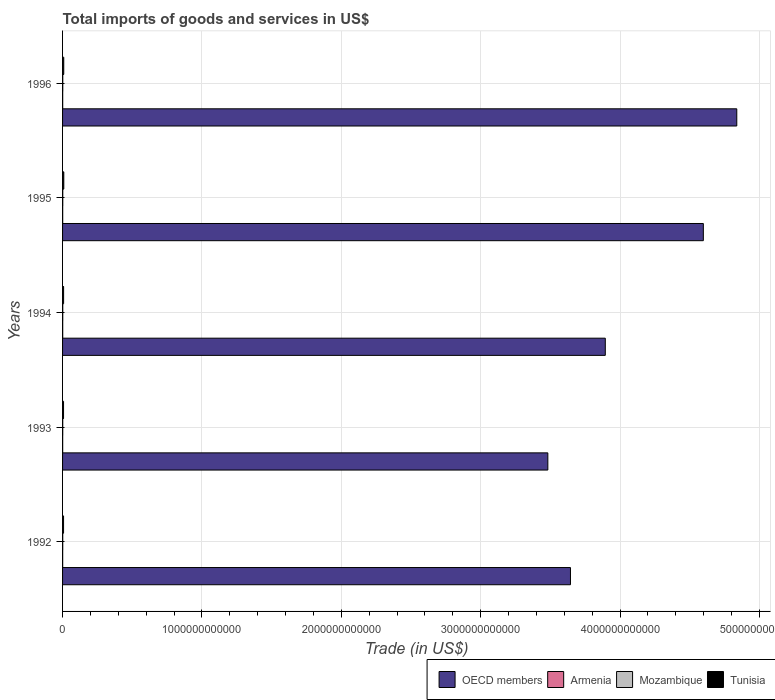How many different coloured bars are there?
Offer a terse response. 4. Are the number of bars per tick equal to the number of legend labels?
Provide a succinct answer. Yes. What is the total imports of goods and services in Mozambique in 1994?
Ensure brevity in your answer.  1.27e+09. Across all years, what is the maximum total imports of goods and services in OECD members?
Make the answer very short. 4.84e+12. Across all years, what is the minimum total imports of goods and services in Tunisia?
Your response must be concise. 7.01e+09. In which year was the total imports of goods and services in Mozambique maximum?
Offer a very short reply. 1995. In which year was the total imports of goods and services in Mozambique minimum?
Offer a terse response. 1993. What is the total total imports of goods and services in Mozambique in the graph?
Your response must be concise. 6.58e+09. What is the difference between the total imports of goods and services in Mozambique in 1993 and that in 1995?
Your answer should be very brief. -2.32e+08. What is the difference between the total imports of goods and services in OECD members in 1994 and the total imports of goods and services in Tunisia in 1995?
Provide a succinct answer. 3.89e+12. What is the average total imports of goods and services in Mozambique per year?
Your answer should be very brief. 1.32e+09. In the year 1992, what is the difference between the total imports of goods and services in OECD members and total imports of goods and services in Mozambique?
Provide a succinct answer. 3.64e+12. In how many years, is the total imports of goods and services in Tunisia greater than 4800000000000 US$?
Your answer should be very brief. 0. What is the ratio of the total imports of goods and services in Armenia in 1993 to that in 1995?
Make the answer very short. 0.8. Is the total imports of goods and services in Armenia in 1992 less than that in 1993?
Your answer should be very brief. No. What is the difference between the highest and the second highest total imports of goods and services in Mozambique?
Your answer should be very brief. 6.62e+06. What is the difference between the highest and the lowest total imports of goods and services in Armenia?
Keep it short and to the point. 2.32e+08. In how many years, is the total imports of goods and services in Mozambique greater than the average total imports of goods and services in Mozambique taken over all years?
Keep it short and to the point. 2. Is it the case that in every year, the sum of the total imports of goods and services in Mozambique and total imports of goods and services in OECD members is greater than the sum of total imports of goods and services in Tunisia and total imports of goods and services in Armenia?
Your answer should be very brief. Yes. What does the 1st bar from the top in 1994 represents?
Your answer should be compact. Tunisia. What does the 1st bar from the bottom in 1996 represents?
Provide a succinct answer. OECD members. Are all the bars in the graph horizontal?
Your answer should be compact. Yes. How many years are there in the graph?
Provide a succinct answer. 5. What is the difference between two consecutive major ticks on the X-axis?
Keep it short and to the point. 1.00e+12. Does the graph contain any zero values?
Provide a succinct answer. No. Where does the legend appear in the graph?
Make the answer very short. Bottom right. How many legend labels are there?
Your response must be concise. 4. How are the legend labels stacked?
Give a very brief answer. Horizontal. What is the title of the graph?
Ensure brevity in your answer.  Total imports of goods and services in US$. What is the label or title of the X-axis?
Give a very brief answer. Trade (in US$). What is the Trade (in US$) in OECD members in 1992?
Your answer should be compact. 3.64e+12. What is the Trade (in US$) in Armenia in 1992?
Your answer should be very brief. 7.80e+08. What is the Trade (in US$) in Mozambique in 1992?
Give a very brief answer. 1.24e+09. What is the Trade (in US$) of Tunisia in 1992?
Provide a short and direct response. 7.20e+09. What is the Trade (in US$) of OECD members in 1993?
Make the answer very short. 3.48e+12. What is the Trade (in US$) in Armenia in 1993?
Provide a short and direct response. 7.30e+08. What is the Trade (in US$) of Mozambique in 1993?
Give a very brief answer. 1.20e+09. What is the Trade (in US$) of Tunisia in 1993?
Ensure brevity in your answer.  7.01e+09. What is the Trade (in US$) of OECD members in 1994?
Provide a succinct answer. 3.89e+12. What is the Trade (in US$) of Armenia in 1994?
Your response must be concise. 9.61e+08. What is the Trade (in US$) of Mozambique in 1994?
Make the answer very short. 1.27e+09. What is the Trade (in US$) of Tunisia in 1994?
Offer a very short reply. 7.48e+09. What is the Trade (in US$) in OECD members in 1995?
Your answer should be very brief. 4.60e+12. What is the Trade (in US$) of Armenia in 1995?
Your answer should be compact. 9.13e+08. What is the Trade (in US$) of Mozambique in 1995?
Your response must be concise. 1.44e+09. What is the Trade (in US$) in Tunisia in 1995?
Your answer should be very brief. 8.80e+09. What is the Trade (in US$) in OECD members in 1996?
Make the answer very short. 4.84e+12. What is the Trade (in US$) in Armenia in 1996?
Your response must be concise. 8.94e+08. What is the Trade (in US$) in Mozambique in 1996?
Provide a succinct answer. 1.43e+09. What is the Trade (in US$) of Tunisia in 1996?
Provide a short and direct response. 8.54e+09. Across all years, what is the maximum Trade (in US$) of OECD members?
Ensure brevity in your answer.  4.84e+12. Across all years, what is the maximum Trade (in US$) of Armenia?
Keep it short and to the point. 9.61e+08. Across all years, what is the maximum Trade (in US$) in Mozambique?
Give a very brief answer. 1.44e+09. Across all years, what is the maximum Trade (in US$) in Tunisia?
Offer a terse response. 8.80e+09. Across all years, what is the minimum Trade (in US$) of OECD members?
Offer a terse response. 3.48e+12. Across all years, what is the minimum Trade (in US$) of Armenia?
Provide a short and direct response. 7.30e+08. Across all years, what is the minimum Trade (in US$) in Mozambique?
Your answer should be very brief. 1.20e+09. Across all years, what is the minimum Trade (in US$) in Tunisia?
Your response must be concise. 7.01e+09. What is the total Trade (in US$) of OECD members in the graph?
Ensure brevity in your answer.  2.05e+13. What is the total Trade (in US$) in Armenia in the graph?
Your response must be concise. 4.28e+09. What is the total Trade (in US$) in Mozambique in the graph?
Your answer should be compact. 6.58e+09. What is the total Trade (in US$) in Tunisia in the graph?
Give a very brief answer. 3.90e+1. What is the difference between the Trade (in US$) of OECD members in 1992 and that in 1993?
Provide a succinct answer. 1.62e+11. What is the difference between the Trade (in US$) of Armenia in 1992 and that in 1993?
Give a very brief answer. 4.97e+07. What is the difference between the Trade (in US$) in Mozambique in 1992 and that in 1993?
Make the answer very short. 3.84e+07. What is the difference between the Trade (in US$) of Tunisia in 1992 and that in 1993?
Offer a very short reply. 1.94e+08. What is the difference between the Trade (in US$) of OECD members in 1992 and that in 1994?
Ensure brevity in your answer.  -2.50e+11. What is the difference between the Trade (in US$) in Armenia in 1992 and that in 1994?
Keep it short and to the point. -1.82e+08. What is the difference between the Trade (in US$) of Mozambique in 1992 and that in 1994?
Your answer should be compact. -3.20e+07. What is the difference between the Trade (in US$) in Tunisia in 1992 and that in 1994?
Your answer should be very brief. -2.83e+08. What is the difference between the Trade (in US$) in OECD members in 1992 and that in 1995?
Give a very brief answer. -9.53e+11. What is the difference between the Trade (in US$) in Armenia in 1992 and that in 1995?
Make the answer very short. -1.34e+08. What is the difference between the Trade (in US$) in Mozambique in 1992 and that in 1995?
Offer a terse response. -1.94e+08. What is the difference between the Trade (in US$) in Tunisia in 1992 and that in 1995?
Provide a succinct answer. -1.60e+09. What is the difference between the Trade (in US$) in OECD members in 1992 and that in 1996?
Your answer should be very brief. -1.19e+12. What is the difference between the Trade (in US$) in Armenia in 1992 and that in 1996?
Your response must be concise. -1.15e+08. What is the difference between the Trade (in US$) in Mozambique in 1992 and that in 1996?
Provide a short and direct response. -1.87e+08. What is the difference between the Trade (in US$) in Tunisia in 1992 and that in 1996?
Offer a very short reply. -1.34e+09. What is the difference between the Trade (in US$) of OECD members in 1993 and that in 1994?
Your answer should be compact. -4.12e+11. What is the difference between the Trade (in US$) of Armenia in 1993 and that in 1994?
Your answer should be compact. -2.32e+08. What is the difference between the Trade (in US$) of Mozambique in 1993 and that in 1994?
Offer a terse response. -7.05e+07. What is the difference between the Trade (in US$) in Tunisia in 1993 and that in 1994?
Your answer should be very brief. -4.76e+08. What is the difference between the Trade (in US$) of OECD members in 1993 and that in 1995?
Your answer should be very brief. -1.12e+12. What is the difference between the Trade (in US$) of Armenia in 1993 and that in 1995?
Your answer should be very brief. -1.83e+08. What is the difference between the Trade (in US$) of Mozambique in 1993 and that in 1995?
Offer a terse response. -2.32e+08. What is the difference between the Trade (in US$) of Tunisia in 1993 and that in 1995?
Provide a short and direct response. -1.79e+09. What is the difference between the Trade (in US$) in OECD members in 1993 and that in 1996?
Your response must be concise. -1.36e+12. What is the difference between the Trade (in US$) of Armenia in 1993 and that in 1996?
Your answer should be very brief. -1.64e+08. What is the difference between the Trade (in US$) of Mozambique in 1993 and that in 1996?
Keep it short and to the point. -2.26e+08. What is the difference between the Trade (in US$) in Tunisia in 1993 and that in 1996?
Your response must be concise. -1.53e+09. What is the difference between the Trade (in US$) in OECD members in 1994 and that in 1995?
Make the answer very short. -7.04e+11. What is the difference between the Trade (in US$) in Armenia in 1994 and that in 1995?
Make the answer very short. 4.83e+07. What is the difference between the Trade (in US$) in Mozambique in 1994 and that in 1995?
Your answer should be very brief. -1.62e+08. What is the difference between the Trade (in US$) in Tunisia in 1994 and that in 1995?
Provide a short and direct response. -1.32e+09. What is the difference between the Trade (in US$) in OECD members in 1994 and that in 1996?
Your answer should be very brief. -9.43e+11. What is the difference between the Trade (in US$) in Armenia in 1994 and that in 1996?
Provide a short and direct response. 6.73e+07. What is the difference between the Trade (in US$) of Mozambique in 1994 and that in 1996?
Offer a terse response. -1.55e+08. What is the difference between the Trade (in US$) in Tunisia in 1994 and that in 1996?
Provide a succinct answer. -1.06e+09. What is the difference between the Trade (in US$) of OECD members in 1995 and that in 1996?
Offer a terse response. -2.40e+11. What is the difference between the Trade (in US$) in Armenia in 1995 and that in 1996?
Make the answer very short. 1.90e+07. What is the difference between the Trade (in US$) in Mozambique in 1995 and that in 1996?
Ensure brevity in your answer.  6.62e+06. What is the difference between the Trade (in US$) of Tunisia in 1995 and that in 1996?
Ensure brevity in your answer.  2.59e+08. What is the difference between the Trade (in US$) in OECD members in 1992 and the Trade (in US$) in Armenia in 1993?
Make the answer very short. 3.64e+12. What is the difference between the Trade (in US$) of OECD members in 1992 and the Trade (in US$) of Mozambique in 1993?
Provide a succinct answer. 3.64e+12. What is the difference between the Trade (in US$) in OECD members in 1992 and the Trade (in US$) in Tunisia in 1993?
Offer a terse response. 3.64e+12. What is the difference between the Trade (in US$) in Armenia in 1992 and the Trade (in US$) in Mozambique in 1993?
Make the answer very short. -4.24e+08. What is the difference between the Trade (in US$) in Armenia in 1992 and the Trade (in US$) in Tunisia in 1993?
Provide a short and direct response. -6.23e+09. What is the difference between the Trade (in US$) of Mozambique in 1992 and the Trade (in US$) of Tunisia in 1993?
Give a very brief answer. -5.77e+09. What is the difference between the Trade (in US$) in OECD members in 1992 and the Trade (in US$) in Armenia in 1994?
Provide a short and direct response. 3.64e+12. What is the difference between the Trade (in US$) in OECD members in 1992 and the Trade (in US$) in Mozambique in 1994?
Your response must be concise. 3.64e+12. What is the difference between the Trade (in US$) in OECD members in 1992 and the Trade (in US$) in Tunisia in 1994?
Give a very brief answer. 3.64e+12. What is the difference between the Trade (in US$) of Armenia in 1992 and the Trade (in US$) of Mozambique in 1994?
Your answer should be compact. -4.94e+08. What is the difference between the Trade (in US$) in Armenia in 1992 and the Trade (in US$) in Tunisia in 1994?
Give a very brief answer. -6.70e+09. What is the difference between the Trade (in US$) of Mozambique in 1992 and the Trade (in US$) of Tunisia in 1994?
Your response must be concise. -6.24e+09. What is the difference between the Trade (in US$) of OECD members in 1992 and the Trade (in US$) of Armenia in 1995?
Make the answer very short. 3.64e+12. What is the difference between the Trade (in US$) of OECD members in 1992 and the Trade (in US$) of Mozambique in 1995?
Give a very brief answer. 3.64e+12. What is the difference between the Trade (in US$) of OECD members in 1992 and the Trade (in US$) of Tunisia in 1995?
Your answer should be very brief. 3.64e+12. What is the difference between the Trade (in US$) in Armenia in 1992 and the Trade (in US$) in Mozambique in 1995?
Your answer should be very brief. -6.56e+08. What is the difference between the Trade (in US$) in Armenia in 1992 and the Trade (in US$) in Tunisia in 1995?
Ensure brevity in your answer.  -8.02e+09. What is the difference between the Trade (in US$) of Mozambique in 1992 and the Trade (in US$) of Tunisia in 1995?
Offer a very short reply. -7.56e+09. What is the difference between the Trade (in US$) in OECD members in 1992 and the Trade (in US$) in Armenia in 1996?
Provide a short and direct response. 3.64e+12. What is the difference between the Trade (in US$) in OECD members in 1992 and the Trade (in US$) in Mozambique in 1996?
Offer a terse response. 3.64e+12. What is the difference between the Trade (in US$) of OECD members in 1992 and the Trade (in US$) of Tunisia in 1996?
Provide a short and direct response. 3.64e+12. What is the difference between the Trade (in US$) of Armenia in 1992 and the Trade (in US$) of Mozambique in 1996?
Give a very brief answer. -6.49e+08. What is the difference between the Trade (in US$) of Armenia in 1992 and the Trade (in US$) of Tunisia in 1996?
Offer a terse response. -7.76e+09. What is the difference between the Trade (in US$) of Mozambique in 1992 and the Trade (in US$) of Tunisia in 1996?
Provide a short and direct response. -7.30e+09. What is the difference between the Trade (in US$) of OECD members in 1993 and the Trade (in US$) of Armenia in 1994?
Provide a short and direct response. 3.48e+12. What is the difference between the Trade (in US$) in OECD members in 1993 and the Trade (in US$) in Mozambique in 1994?
Offer a terse response. 3.48e+12. What is the difference between the Trade (in US$) in OECD members in 1993 and the Trade (in US$) in Tunisia in 1994?
Provide a short and direct response. 3.47e+12. What is the difference between the Trade (in US$) of Armenia in 1993 and the Trade (in US$) of Mozambique in 1994?
Your answer should be compact. -5.44e+08. What is the difference between the Trade (in US$) of Armenia in 1993 and the Trade (in US$) of Tunisia in 1994?
Your answer should be very brief. -6.75e+09. What is the difference between the Trade (in US$) in Mozambique in 1993 and the Trade (in US$) in Tunisia in 1994?
Your answer should be compact. -6.28e+09. What is the difference between the Trade (in US$) in OECD members in 1993 and the Trade (in US$) in Armenia in 1995?
Your answer should be compact. 3.48e+12. What is the difference between the Trade (in US$) of OECD members in 1993 and the Trade (in US$) of Mozambique in 1995?
Provide a short and direct response. 3.48e+12. What is the difference between the Trade (in US$) of OECD members in 1993 and the Trade (in US$) of Tunisia in 1995?
Offer a very short reply. 3.47e+12. What is the difference between the Trade (in US$) in Armenia in 1993 and the Trade (in US$) in Mozambique in 1995?
Provide a succinct answer. -7.06e+08. What is the difference between the Trade (in US$) in Armenia in 1993 and the Trade (in US$) in Tunisia in 1995?
Offer a terse response. -8.07e+09. What is the difference between the Trade (in US$) of Mozambique in 1993 and the Trade (in US$) of Tunisia in 1995?
Provide a short and direct response. -7.60e+09. What is the difference between the Trade (in US$) in OECD members in 1993 and the Trade (in US$) in Armenia in 1996?
Provide a short and direct response. 3.48e+12. What is the difference between the Trade (in US$) in OECD members in 1993 and the Trade (in US$) in Mozambique in 1996?
Provide a short and direct response. 3.48e+12. What is the difference between the Trade (in US$) of OECD members in 1993 and the Trade (in US$) of Tunisia in 1996?
Ensure brevity in your answer.  3.47e+12. What is the difference between the Trade (in US$) in Armenia in 1993 and the Trade (in US$) in Mozambique in 1996?
Provide a short and direct response. -6.99e+08. What is the difference between the Trade (in US$) of Armenia in 1993 and the Trade (in US$) of Tunisia in 1996?
Give a very brief answer. -7.81e+09. What is the difference between the Trade (in US$) in Mozambique in 1993 and the Trade (in US$) in Tunisia in 1996?
Offer a terse response. -7.34e+09. What is the difference between the Trade (in US$) in OECD members in 1994 and the Trade (in US$) in Armenia in 1995?
Offer a very short reply. 3.89e+12. What is the difference between the Trade (in US$) of OECD members in 1994 and the Trade (in US$) of Mozambique in 1995?
Provide a succinct answer. 3.89e+12. What is the difference between the Trade (in US$) in OECD members in 1994 and the Trade (in US$) in Tunisia in 1995?
Give a very brief answer. 3.89e+12. What is the difference between the Trade (in US$) of Armenia in 1994 and the Trade (in US$) of Mozambique in 1995?
Your answer should be compact. -4.74e+08. What is the difference between the Trade (in US$) in Armenia in 1994 and the Trade (in US$) in Tunisia in 1995?
Provide a succinct answer. -7.84e+09. What is the difference between the Trade (in US$) of Mozambique in 1994 and the Trade (in US$) of Tunisia in 1995?
Give a very brief answer. -7.53e+09. What is the difference between the Trade (in US$) in OECD members in 1994 and the Trade (in US$) in Armenia in 1996?
Provide a succinct answer. 3.89e+12. What is the difference between the Trade (in US$) in OECD members in 1994 and the Trade (in US$) in Mozambique in 1996?
Provide a short and direct response. 3.89e+12. What is the difference between the Trade (in US$) in OECD members in 1994 and the Trade (in US$) in Tunisia in 1996?
Provide a succinct answer. 3.89e+12. What is the difference between the Trade (in US$) in Armenia in 1994 and the Trade (in US$) in Mozambique in 1996?
Offer a terse response. -4.67e+08. What is the difference between the Trade (in US$) in Armenia in 1994 and the Trade (in US$) in Tunisia in 1996?
Give a very brief answer. -7.58e+09. What is the difference between the Trade (in US$) in Mozambique in 1994 and the Trade (in US$) in Tunisia in 1996?
Provide a short and direct response. -7.27e+09. What is the difference between the Trade (in US$) in OECD members in 1995 and the Trade (in US$) in Armenia in 1996?
Provide a succinct answer. 4.60e+12. What is the difference between the Trade (in US$) of OECD members in 1995 and the Trade (in US$) of Mozambique in 1996?
Provide a succinct answer. 4.60e+12. What is the difference between the Trade (in US$) of OECD members in 1995 and the Trade (in US$) of Tunisia in 1996?
Give a very brief answer. 4.59e+12. What is the difference between the Trade (in US$) of Armenia in 1995 and the Trade (in US$) of Mozambique in 1996?
Ensure brevity in your answer.  -5.16e+08. What is the difference between the Trade (in US$) of Armenia in 1995 and the Trade (in US$) of Tunisia in 1996?
Offer a very short reply. -7.63e+09. What is the difference between the Trade (in US$) in Mozambique in 1995 and the Trade (in US$) in Tunisia in 1996?
Offer a terse response. -7.11e+09. What is the average Trade (in US$) of OECD members per year?
Provide a succinct answer. 4.09e+12. What is the average Trade (in US$) in Armenia per year?
Offer a very short reply. 8.56e+08. What is the average Trade (in US$) in Mozambique per year?
Your response must be concise. 1.32e+09. What is the average Trade (in US$) in Tunisia per year?
Ensure brevity in your answer.  7.81e+09. In the year 1992, what is the difference between the Trade (in US$) of OECD members and Trade (in US$) of Armenia?
Ensure brevity in your answer.  3.64e+12. In the year 1992, what is the difference between the Trade (in US$) of OECD members and Trade (in US$) of Mozambique?
Give a very brief answer. 3.64e+12. In the year 1992, what is the difference between the Trade (in US$) in OECD members and Trade (in US$) in Tunisia?
Give a very brief answer. 3.64e+12. In the year 1992, what is the difference between the Trade (in US$) of Armenia and Trade (in US$) of Mozambique?
Keep it short and to the point. -4.62e+08. In the year 1992, what is the difference between the Trade (in US$) of Armenia and Trade (in US$) of Tunisia?
Offer a terse response. -6.42e+09. In the year 1992, what is the difference between the Trade (in US$) of Mozambique and Trade (in US$) of Tunisia?
Keep it short and to the point. -5.96e+09. In the year 1993, what is the difference between the Trade (in US$) of OECD members and Trade (in US$) of Armenia?
Provide a succinct answer. 3.48e+12. In the year 1993, what is the difference between the Trade (in US$) of OECD members and Trade (in US$) of Mozambique?
Give a very brief answer. 3.48e+12. In the year 1993, what is the difference between the Trade (in US$) in OECD members and Trade (in US$) in Tunisia?
Keep it short and to the point. 3.48e+12. In the year 1993, what is the difference between the Trade (in US$) in Armenia and Trade (in US$) in Mozambique?
Give a very brief answer. -4.73e+08. In the year 1993, what is the difference between the Trade (in US$) of Armenia and Trade (in US$) of Tunisia?
Provide a succinct answer. -6.28e+09. In the year 1993, what is the difference between the Trade (in US$) in Mozambique and Trade (in US$) in Tunisia?
Ensure brevity in your answer.  -5.80e+09. In the year 1994, what is the difference between the Trade (in US$) in OECD members and Trade (in US$) in Armenia?
Offer a very short reply. 3.89e+12. In the year 1994, what is the difference between the Trade (in US$) of OECD members and Trade (in US$) of Mozambique?
Your answer should be compact. 3.89e+12. In the year 1994, what is the difference between the Trade (in US$) in OECD members and Trade (in US$) in Tunisia?
Provide a succinct answer. 3.89e+12. In the year 1994, what is the difference between the Trade (in US$) in Armenia and Trade (in US$) in Mozambique?
Your answer should be compact. -3.12e+08. In the year 1994, what is the difference between the Trade (in US$) of Armenia and Trade (in US$) of Tunisia?
Provide a succinct answer. -6.52e+09. In the year 1994, what is the difference between the Trade (in US$) of Mozambique and Trade (in US$) of Tunisia?
Your answer should be very brief. -6.21e+09. In the year 1995, what is the difference between the Trade (in US$) in OECD members and Trade (in US$) in Armenia?
Offer a terse response. 4.60e+12. In the year 1995, what is the difference between the Trade (in US$) in OECD members and Trade (in US$) in Mozambique?
Your answer should be very brief. 4.60e+12. In the year 1995, what is the difference between the Trade (in US$) in OECD members and Trade (in US$) in Tunisia?
Provide a short and direct response. 4.59e+12. In the year 1995, what is the difference between the Trade (in US$) of Armenia and Trade (in US$) of Mozambique?
Your answer should be very brief. -5.22e+08. In the year 1995, what is the difference between the Trade (in US$) in Armenia and Trade (in US$) in Tunisia?
Offer a very short reply. -7.89e+09. In the year 1995, what is the difference between the Trade (in US$) in Mozambique and Trade (in US$) in Tunisia?
Your answer should be compact. -7.37e+09. In the year 1996, what is the difference between the Trade (in US$) of OECD members and Trade (in US$) of Armenia?
Provide a succinct answer. 4.84e+12. In the year 1996, what is the difference between the Trade (in US$) of OECD members and Trade (in US$) of Mozambique?
Provide a succinct answer. 4.84e+12. In the year 1996, what is the difference between the Trade (in US$) in OECD members and Trade (in US$) in Tunisia?
Make the answer very short. 4.83e+12. In the year 1996, what is the difference between the Trade (in US$) of Armenia and Trade (in US$) of Mozambique?
Your answer should be compact. -5.35e+08. In the year 1996, what is the difference between the Trade (in US$) in Armenia and Trade (in US$) in Tunisia?
Your answer should be very brief. -7.65e+09. In the year 1996, what is the difference between the Trade (in US$) of Mozambique and Trade (in US$) of Tunisia?
Your answer should be compact. -7.11e+09. What is the ratio of the Trade (in US$) of OECD members in 1992 to that in 1993?
Keep it short and to the point. 1.05. What is the ratio of the Trade (in US$) of Armenia in 1992 to that in 1993?
Your answer should be compact. 1.07. What is the ratio of the Trade (in US$) of Mozambique in 1992 to that in 1993?
Keep it short and to the point. 1.03. What is the ratio of the Trade (in US$) in Tunisia in 1992 to that in 1993?
Offer a terse response. 1.03. What is the ratio of the Trade (in US$) in OECD members in 1992 to that in 1994?
Your response must be concise. 0.94. What is the ratio of the Trade (in US$) of Armenia in 1992 to that in 1994?
Your response must be concise. 0.81. What is the ratio of the Trade (in US$) in Mozambique in 1992 to that in 1994?
Give a very brief answer. 0.97. What is the ratio of the Trade (in US$) of Tunisia in 1992 to that in 1994?
Your answer should be very brief. 0.96. What is the ratio of the Trade (in US$) of OECD members in 1992 to that in 1995?
Give a very brief answer. 0.79. What is the ratio of the Trade (in US$) in Armenia in 1992 to that in 1995?
Make the answer very short. 0.85. What is the ratio of the Trade (in US$) of Mozambique in 1992 to that in 1995?
Provide a short and direct response. 0.86. What is the ratio of the Trade (in US$) of Tunisia in 1992 to that in 1995?
Ensure brevity in your answer.  0.82. What is the ratio of the Trade (in US$) of OECD members in 1992 to that in 1996?
Your answer should be very brief. 0.75. What is the ratio of the Trade (in US$) in Armenia in 1992 to that in 1996?
Provide a succinct answer. 0.87. What is the ratio of the Trade (in US$) of Mozambique in 1992 to that in 1996?
Keep it short and to the point. 0.87. What is the ratio of the Trade (in US$) in Tunisia in 1992 to that in 1996?
Provide a succinct answer. 0.84. What is the ratio of the Trade (in US$) of OECD members in 1993 to that in 1994?
Keep it short and to the point. 0.89. What is the ratio of the Trade (in US$) in Armenia in 1993 to that in 1994?
Your response must be concise. 0.76. What is the ratio of the Trade (in US$) in Mozambique in 1993 to that in 1994?
Provide a succinct answer. 0.94. What is the ratio of the Trade (in US$) of Tunisia in 1993 to that in 1994?
Your response must be concise. 0.94. What is the ratio of the Trade (in US$) in OECD members in 1993 to that in 1995?
Ensure brevity in your answer.  0.76. What is the ratio of the Trade (in US$) of Armenia in 1993 to that in 1995?
Provide a succinct answer. 0.8. What is the ratio of the Trade (in US$) in Mozambique in 1993 to that in 1995?
Your answer should be compact. 0.84. What is the ratio of the Trade (in US$) in Tunisia in 1993 to that in 1995?
Your answer should be very brief. 0.8. What is the ratio of the Trade (in US$) of OECD members in 1993 to that in 1996?
Offer a terse response. 0.72. What is the ratio of the Trade (in US$) in Armenia in 1993 to that in 1996?
Give a very brief answer. 0.82. What is the ratio of the Trade (in US$) in Mozambique in 1993 to that in 1996?
Give a very brief answer. 0.84. What is the ratio of the Trade (in US$) of Tunisia in 1993 to that in 1996?
Your answer should be compact. 0.82. What is the ratio of the Trade (in US$) in OECD members in 1994 to that in 1995?
Your answer should be very brief. 0.85. What is the ratio of the Trade (in US$) of Armenia in 1994 to that in 1995?
Your answer should be very brief. 1.05. What is the ratio of the Trade (in US$) of Mozambique in 1994 to that in 1995?
Your answer should be very brief. 0.89. What is the ratio of the Trade (in US$) of Tunisia in 1994 to that in 1995?
Offer a very short reply. 0.85. What is the ratio of the Trade (in US$) of OECD members in 1994 to that in 1996?
Provide a short and direct response. 0.81. What is the ratio of the Trade (in US$) of Armenia in 1994 to that in 1996?
Your answer should be compact. 1.08. What is the ratio of the Trade (in US$) in Mozambique in 1994 to that in 1996?
Offer a terse response. 0.89. What is the ratio of the Trade (in US$) in Tunisia in 1994 to that in 1996?
Your answer should be compact. 0.88. What is the ratio of the Trade (in US$) in OECD members in 1995 to that in 1996?
Provide a short and direct response. 0.95. What is the ratio of the Trade (in US$) of Armenia in 1995 to that in 1996?
Your answer should be compact. 1.02. What is the ratio of the Trade (in US$) in Tunisia in 1995 to that in 1996?
Keep it short and to the point. 1.03. What is the difference between the highest and the second highest Trade (in US$) of OECD members?
Offer a very short reply. 2.40e+11. What is the difference between the highest and the second highest Trade (in US$) in Armenia?
Your answer should be compact. 4.83e+07. What is the difference between the highest and the second highest Trade (in US$) of Mozambique?
Provide a succinct answer. 6.62e+06. What is the difference between the highest and the second highest Trade (in US$) in Tunisia?
Your response must be concise. 2.59e+08. What is the difference between the highest and the lowest Trade (in US$) of OECD members?
Provide a short and direct response. 1.36e+12. What is the difference between the highest and the lowest Trade (in US$) in Armenia?
Provide a succinct answer. 2.32e+08. What is the difference between the highest and the lowest Trade (in US$) of Mozambique?
Offer a terse response. 2.32e+08. What is the difference between the highest and the lowest Trade (in US$) of Tunisia?
Your answer should be very brief. 1.79e+09. 